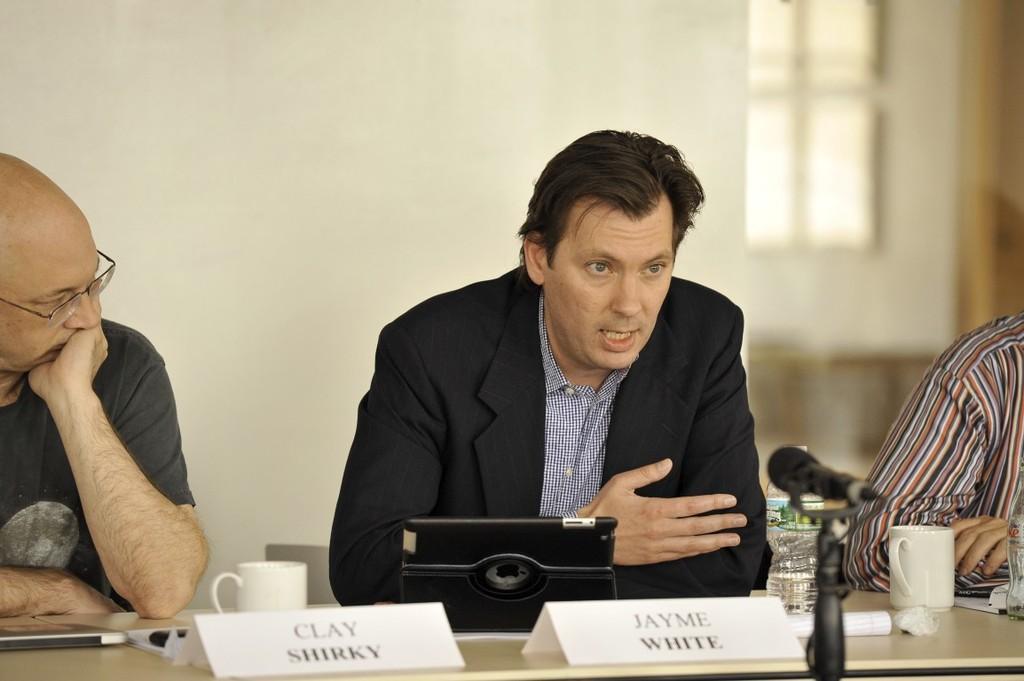In one or two sentences, can you explain what this image depicts? In the image we can see two men sitting, wearing clothes and the left side men is wearing spectacles. Here we can see a table, on the table, we can see tea cup, bottle and name plate. Beside these two men there is another person sitting. Here we can see a gadget, microphone and the background is blurred. 